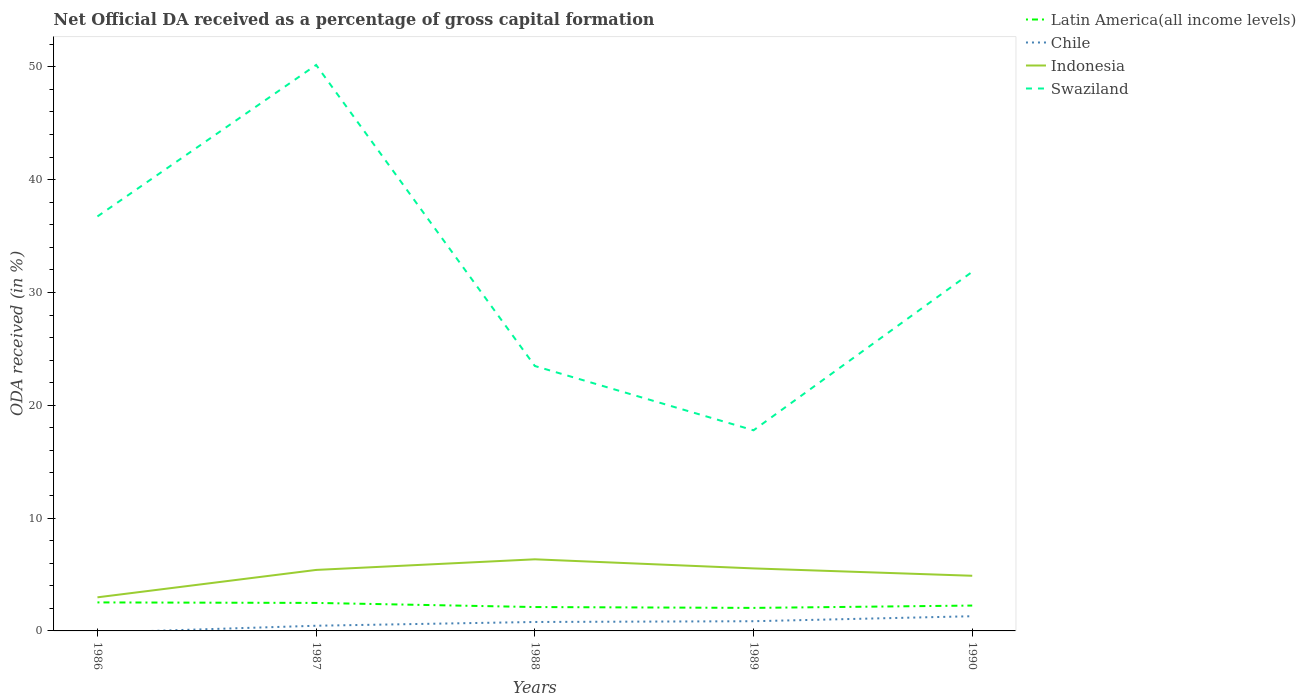Is the number of lines equal to the number of legend labels?
Your response must be concise. No. Across all years, what is the maximum net ODA received in Swaziland?
Offer a very short reply. 17.78. What is the total net ODA received in Swaziland in the graph?
Provide a short and direct response. 18.96. What is the difference between the highest and the second highest net ODA received in Chile?
Make the answer very short. 1.3. Is the net ODA received in Indonesia strictly greater than the net ODA received in Chile over the years?
Provide a short and direct response. No. How many lines are there?
Your answer should be compact. 4. How many years are there in the graph?
Offer a very short reply. 5. What is the difference between two consecutive major ticks on the Y-axis?
Offer a terse response. 10. Does the graph contain any zero values?
Make the answer very short. Yes. Does the graph contain grids?
Give a very brief answer. No. How are the legend labels stacked?
Make the answer very short. Vertical. What is the title of the graph?
Keep it short and to the point. Net Official DA received as a percentage of gross capital formation. Does "Belarus" appear as one of the legend labels in the graph?
Your response must be concise. No. What is the label or title of the X-axis?
Provide a short and direct response. Years. What is the label or title of the Y-axis?
Ensure brevity in your answer.  ODA received (in %). What is the ODA received (in %) of Latin America(all income levels) in 1986?
Your answer should be very brief. 2.53. What is the ODA received (in %) of Indonesia in 1986?
Your response must be concise. 2.98. What is the ODA received (in %) of Swaziland in 1986?
Provide a succinct answer. 36.74. What is the ODA received (in %) in Latin America(all income levels) in 1987?
Provide a succinct answer. 2.48. What is the ODA received (in %) of Chile in 1987?
Give a very brief answer. 0.46. What is the ODA received (in %) in Indonesia in 1987?
Keep it short and to the point. 5.41. What is the ODA received (in %) in Swaziland in 1987?
Offer a very short reply. 50.17. What is the ODA received (in %) of Latin America(all income levels) in 1988?
Your answer should be compact. 2.12. What is the ODA received (in %) of Chile in 1988?
Offer a terse response. 0.79. What is the ODA received (in %) in Indonesia in 1988?
Give a very brief answer. 6.35. What is the ODA received (in %) of Swaziland in 1988?
Ensure brevity in your answer.  23.48. What is the ODA received (in %) of Latin America(all income levels) in 1989?
Offer a terse response. 2.04. What is the ODA received (in %) of Chile in 1989?
Ensure brevity in your answer.  0.86. What is the ODA received (in %) in Indonesia in 1989?
Your response must be concise. 5.54. What is the ODA received (in %) of Swaziland in 1989?
Your response must be concise. 17.78. What is the ODA received (in %) of Latin America(all income levels) in 1990?
Your answer should be compact. 2.25. What is the ODA received (in %) in Chile in 1990?
Your answer should be very brief. 1.3. What is the ODA received (in %) in Indonesia in 1990?
Your answer should be compact. 4.89. What is the ODA received (in %) of Swaziland in 1990?
Give a very brief answer. 31.83. Across all years, what is the maximum ODA received (in %) in Latin America(all income levels)?
Your response must be concise. 2.53. Across all years, what is the maximum ODA received (in %) of Chile?
Provide a short and direct response. 1.3. Across all years, what is the maximum ODA received (in %) of Indonesia?
Offer a very short reply. 6.35. Across all years, what is the maximum ODA received (in %) in Swaziland?
Your answer should be compact. 50.17. Across all years, what is the minimum ODA received (in %) in Latin America(all income levels)?
Your answer should be very brief. 2.04. Across all years, what is the minimum ODA received (in %) of Indonesia?
Keep it short and to the point. 2.98. Across all years, what is the minimum ODA received (in %) in Swaziland?
Your answer should be very brief. 17.78. What is the total ODA received (in %) of Latin America(all income levels) in the graph?
Your answer should be compact. 11.42. What is the total ODA received (in %) of Chile in the graph?
Your answer should be very brief. 3.42. What is the total ODA received (in %) of Indonesia in the graph?
Ensure brevity in your answer.  25.16. What is the total ODA received (in %) of Swaziland in the graph?
Provide a short and direct response. 160.01. What is the difference between the ODA received (in %) of Latin America(all income levels) in 1986 and that in 1987?
Offer a very short reply. 0.04. What is the difference between the ODA received (in %) of Indonesia in 1986 and that in 1987?
Your response must be concise. -2.43. What is the difference between the ODA received (in %) of Swaziland in 1986 and that in 1987?
Offer a terse response. -13.43. What is the difference between the ODA received (in %) in Latin America(all income levels) in 1986 and that in 1988?
Your answer should be compact. 0.41. What is the difference between the ODA received (in %) in Indonesia in 1986 and that in 1988?
Make the answer very short. -3.37. What is the difference between the ODA received (in %) in Swaziland in 1986 and that in 1988?
Offer a terse response. 13.26. What is the difference between the ODA received (in %) of Latin America(all income levels) in 1986 and that in 1989?
Your response must be concise. 0.49. What is the difference between the ODA received (in %) in Indonesia in 1986 and that in 1989?
Your response must be concise. -2.56. What is the difference between the ODA received (in %) of Swaziland in 1986 and that in 1989?
Make the answer very short. 18.96. What is the difference between the ODA received (in %) of Latin America(all income levels) in 1986 and that in 1990?
Make the answer very short. 0.28. What is the difference between the ODA received (in %) in Indonesia in 1986 and that in 1990?
Offer a terse response. -1.91. What is the difference between the ODA received (in %) in Swaziland in 1986 and that in 1990?
Offer a terse response. 4.91. What is the difference between the ODA received (in %) in Latin America(all income levels) in 1987 and that in 1988?
Your answer should be compact. 0.37. What is the difference between the ODA received (in %) in Chile in 1987 and that in 1988?
Provide a short and direct response. -0.33. What is the difference between the ODA received (in %) in Indonesia in 1987 and that in 1988?
Make the answer very short. -0.94. What is the difference between the ODA received (in %) of Swaziland in 1987 and that in 1988?
Keep it short and to the point. 26.69. What is the difference between the ODA received (in %) of Latin America(all income levels) in 1987 and that in 1989?
Make the answer very short. 0.44. What is the difference between the ODA received (in %) in Chile in 1987 and that in 1989?
Keep it short and to the point. -0.4. What is the difference between the ODA received (in %) in Indonesia in 1987 and that in 1989?
Offer a very short reply. -0.13. What is the difference between the ODA received (in %) in Swaziland in 1987 and that in 1989?
Offer a terse response. 32.38. What is the difference between the ODA received (in %) in Latin America(all income levels) in 1987 and that in 1990?
Your answer should be compact. 0.23. What is the difference between the ODA received (in %) of Chile in 1987 and that in 1990?
Ensure brevity in your answer.  -0.84. What is the difference between the ODA received (in %) of Indonesia in 1987 and that in 1990?
Offer a terse response. 0.52. What is the difference between the ODA received (in %) of Swaziland in 1987 and that in 1990?
Provide a succinct answer. 18.34. What is the difference between the ODA received (in %) in Latin America(all income levels) in 1988 and that in 1989?
Provide a succinct answer. 0.08. What is the difference between the ODA received (in %) of Chile in 1988 and that in 1989?
Keep it short and to the point. -0.07. What is the difference between the ODA received (in %) in Indonesia in 1988 and that in 1989?
Provide a short and direct response. 0.81. What is the difference between the ODA received (in %) in Swaziland in 1988 and that in 1989?
Provide a succinct answer. 5.7. What is the difference between the ODA received (in %) of Latin America(all income levels) in 1988 and that in 1990?
Give a very brief answer. -0.13. What is the difference between the ODA received (in %) in Chile in 1988 and that in 1990?
Ensure brevity in your answer.  -0.51. What is the difference between the ODA received (in %) of Indonesia in 1988 and that in 1990?
Your answer should be compact. 1.46. What is the difference between the ODA received (in %) in Swaziland in 1988 and that in 1990?
Provide a succinct answer. -8.35. What is the difference between the ODA received (in %) in Latin America(all income levels) in 1989 and that in 1990?
Provide a succinct answer. -0.21. What is the difference between the ODA received (in %) in Chile in 1989 and that in 1990?
Your response must be concise. -0.44. What is the difference between the ODA received (in %) of Indonesia in 1989 and that in 1990?
Offer a terse response. 0.65. What is the difference between the ODA received (in %) in Swaziland in 1989 and that in 1990?
Make the answer very short. -14.05. What is the difference between the ODA received (in %) of Latin America(all income levels) in 1986 and the ODA received (in %) of Chile in 1987?
Your answer should be very brief. 2.07. What is the difference between the ODA received (in %) of Latin America(all income levels) in 1986 and the ODA received (in %) of Indonesia in 1987?
Give a very brief answer. -2.88. What is the difference between the ODA received (in %) in Latin America(all income levels) in 1986 and the ODA received (in %) in Swaziland in 1987?
Your answer should be compact. -47.64. What is the difference between the ODA received (in %) of Indonesia in 1986 and the ODA received (in %) of Swaziland in 1987?
Make the answer very short. -47.19. What is the difference between the ODA received (in %) of Latin America(all income levels) in 1986 and the ODA received (in %) of Chile in 1988?
Give a very brief answer. 1.73. What is the difference between the ODA received (in %) of Latin America(all income levels) in 1986 and the ODA received (in %) of Indonesia in 1988?
Give a very brief answer. -3.82. What is the difference between the ODA received (in %) of Latin America(all income levels) in 1986 and the ODA received (in %) of Swaziland in 1988?
Your answer should be compact. -20.96. What is the difference between the ODA received (in %) of Indonesia in 1986 and the ODA received (in %) of Swaziland in 1988?
Make the answer very short. -20.5. What is the difference between the ODA received (in %) in Latin America(all income levels) in 1986 and the ODA received (in %) in Chile in 1989?
Provide a succinct answer. 1.67. What is the difference between the ODA received (in %) in Latin America(all income levels) in 1986 and the ODA received (in %) in Indonesia in 1989?
Your answer should be compact. -3.01. What is the difference between the ODA received (in %) in Latin America(all income levels) in 1986 and the ODA received (in %) in Swaziland in 1989?
Ensure brevity in your answer.  -15.26. What is the difference between the ODA received (in %) of Indonesia in 1986 and the ODA received (in %) of Swaziland in 1989?
Offer a terse response. -14.81. What is the difference between the ODA received (in %) in Latin America(all income levels) in 1986 and the ODA received (in %) in Chile in 1990?
Offer a terse response. 1.22. What is the difference between the ODA received (in %) of Latin America(all income levels) in 1986 and the ODA received (in %) of Indonesia in 1990?
Provide a short and direct response. -2.36. What is the difference between the ODA received (in %) of Latin America(all income levels) in 1986 and the ODA received (in %) of Swaziland in 1990?
Your answer should be compact. -29.31. What is the difference between the ODA received (in %) in Indonesia in 1986 and the ODA received (in %) in Swaziland in 1990?
Provide a short and direct response. -28.85. What is the difference between the ODA received (in %) in Latin America(all income levels) in 1987 and the ODA received (in %) in Chile in 1988?
Give a very brief answer. 1.69. What is the difference between the ODA received (in %) of Latin America(all income levels) in 1987 and the ODA received (in %) of Indonesia in 1988?
Your answer should be compact. -3.87. What is the difference between the ODA received (in %) of Latin America(all income levels) in 1987 and the ODA received (in %) of Swaziland in 1988?
Your answer should be compact. -21. What is the difference between the ODA received (in %) of Chile in 1987 and the ODA received (in %) of Indonesia in 1988?
Offer a terse response. -5.89. What is the difference between the ODA received (in %) of Chile in 1987 and the ODA received (in %) of Swaziland in 1988?
Give a very brief answer. -23.02. What is the difference between the ODA received (in %) of Indonesia in 1987 and the ODA received (in %) of Swaziland in 1988?
Your answer should be compact. -18.08. What is the difference between the ODA received (in %) in Latin America(all income levels) in 1987 and the ODA received (in %) in Chile in 1989?
Your answer should be very brief. 1.62. What is the difference between the ODA received (in %) of Latin America(all income levels) in 1987 and the ODA received (in %) of Indonesia in 1989?
Offer a terse response. -3.06. What is the difference between the ODA received (in %) in Latin America(all income levels) in 1987 and the ODA received (in %) in Swaziland in 1989?
Ensure brevity in your answer.  -15.3. What is the difference between the ODA received (in %) in Chile in 1987 and the ODA received (in %) in Indonesia in 1989?
Make the answer very short. -5.08. What is the difference between the ODA received (in %) of Chile in 1987 and the ODA received (in %) of Swaziland in 1989?
Your answer should be very brief. -17.32. What is the difference between the ODA received (in %) in Indonesia in 1987 and the ODA received (in %) in Swaziland in 1989?
Your answer should be compact. -12.38. What is the difference between the ODA received (in %) in Latin America(all income levels) in 1987 and the ODA received (in %) in Chile in 1990?
Offer a very short reply. 1.18. What is the difference between the ODA received (in %) of Latin America(all income levels) in 1987 and the ODA received (in %) of Indonesia in 1990?
Ensure brevity in your answer.  -2.41. What is the difference between the ODA received (in %) in Latin America(all income levels) in 1987 and the ODA received (in %) in Swaziland in 1990?
Provide a succinct answer. -29.35. What is the difference between the ODA received (in %) in Chile in 1987 and the ODA received (in %) in Indonesia in 1990?
Your response must be concise. -4.43. What is the difference between the ODA received (in %) in Chile in 1987 and the ODA received (in %) in Swaziland in 1990?
Provide a short and direct response. -31.37. What is the difference between the ODA received (in %) in Indonesia in 1987 and the ODA received (in %) in Swaziland in 1990?
Your answer should be compact. -26.43. What is the difference between the ODA received (in %) of Latin America(all income levels) in 1988 and the ODA received (in %) of Chile in 1989?
Provide a succinct answer. 1.26. What is the difference between the ODA received (in %) of Latin America(all income levels) in 1988 and the ODA received (in %) of Indonesia in 1989?
Keep it short and to the point. -3.42. What is the difference between the ODA received (in %) in Latin America(all income levels) in 1988 and the ODA received (in %) in Swaziland in 1989?
Your answer should be very brief. -15.67. What is the difference between the ODA received (in %) in Chile in 1988 and the ODA received (in %) in Indonesia in 1989?
Your answer should be compact. -4.75. What is the difference between the ODA received (in %) in Chile in 1988 and the ODA received (in %) in Swaziland in 1989?
Provide a short and direct response. -16.99. What is the difference between the ODA received (in %) in Indonesia in 1988 and the ODA received (in %) in Swaziland in 1989?
Give a very brief answer. -11.44. What is the difference between the ODA received (in %) of Latin America(all income levels) in 1988 and the ODA received (in %) of Chile in 1990?
Ensure brevity in your answer.  0.81. What is the difference between the ODA received (in %) of Latin America(all income levels) in 1988 and the ODA received (in %) of Indonesia in 1990?
Give a very brief answer. -2.77. What is the difference between the ODA received (in %) in Latin America(all income levels) in 1988 and the ODA received (in %) in Swaziland in 1990?
Make the answer very short. -29.72. What is the difference between the ODA received (in %) of Chile in 1988 and the ODA received (in %) of Indonesia in 1990?
Ensure brevity in your answer.  -4.1. What is the difference between the ODA received (in %) of Chile in 1988 and the ODA received (in %) of Swaziland in 1990?
Offer a very short reply. -31.04. What is the difference between the ODA received (in %) in Indonesia in 1988 and the ODA received (in %) in Swaziland in 1990?
Ensure brevity in your answer.  -25.48. What is the difference between the ODA received (in %) of Latin America(all income levels) in 1989 and the ODA received (in %) of Chile in 1990?
Provide a succinct answer. 0.74. What is the difference between the ODA received (in %) in Latin America(all income levels) in 1989 and the ODA received (in %) in Indonesia in 1990?
Keep it short and to the point. -2.85. What is the difference between the ODA received (in %) of Latin America(all income levels) in 1989 and the ODA received (in %) of Swaziland in 1990?
Provide a short and direct response. -29.79. What is the difference between the ODA received (in %) of Chile in 1989 and the ODA received (in %) of Indonesia in 1990?
Offer a very short reply. -4.03. What is the difference between the ODA received (in %) in Chile in 1989 and the ODA received (in %) in Swaziland in 1990?
Offer a terse response. -30.97. What is the difference between the ODA received (in %) of Indonesia in 1989 and the ODA received (in %) of Swaziland in 1990?
Your answer should be compact. -26.29. What is the average ODA received (in %) of Latin America(all income levels) per year?
Keep it short and to the point. 2.28. What is the average ODA received (in %) of Chile per year?
Keep it short and to the point. 0.68. What is the average ODA received (in %) of Indonesia per year?
Your response must be concise. 5.03. What is the average ODA received (in %) in Swaziland per year?
Make the answer very short. 32. In the year 1986, what is the difference between the ODA received (in %) in Latin America(all income levels) and ODA received (in %) in Indonesia?
Give a very brief answer. -0.45. In the year 1986, what is the difference between the ODA received (in %) in Latin America(all income levels) and ODA received (in %) in Swaziland?
Provide a succinct answer. -34.21. In the year 1986, what is the difference between the ODA received (in %) in Indonesia and ODA received (in %) in Swaziland?
Your answer should be very brief. -33.76. In the year 1987, what is the difference between the ODA received (in %) in Latin America(all income levels) and ODA received (in %) in Chile?
Keep it short and to the point. 2.02. In the year 1987, what is the difference between the ODA received (in %) of Latin America(all income levels) and ODA received (in %) of Indonesia?
Your response must be concise. -2.92. In the year 1987, what is the difference between the ODA received (in %) in Latin America(all income levels) and ODA received (in %) in Swaziland?
Ensure brevity in your answer.  -47.69. In the year 1987, what is the difference between the ODA received (in %) of Chile and ODA received (in %) of Indonesia?
Provide a short and direct response. -4.95. In the year 1987, what is the difference between the ODA received (in %) in Chile and ODA received (in %) in Swaziland?
Ensure brevity in your answer.  -49.71. In the year 1987, what is the difference between the ODA received (in %) in Indonesia and ODA received (in %) in Swaziland?
Make the answer very short. -44.76. In the year 1988, what is the difference between the ODA received (in %) of Latin America(all income levels) and ODA received (in %) of Chile?
Provide a short and direct response. 1.32. In the year 1988, what is the difference between the ODA received (in %) in Latin America(all income levels) and ODA received (in %) in Indonesia?
Provide a short and direct response. -4.23. In the year 1988, what is the difference between the ODA received (in %) of Latin America(all income levels) and ODA received (in %) of Swaziland?
Keep it short and to the point. -21.37. In the year 1988, what is the difference between the ODA received (in %) in Chile and ODA received (in %) in Indonesia?
Keep it short and to the point. -5.55. In the year 1988, what is the difference between the ODA received (in %) in Chile and ODA received (in %) in Swaziland?
Offer a terse response. -22.69. In the year 1988, what is the difference between the ODA received (in %) of Indonesia and ODA received (in %) of Swaziland?
Provide a succinct answer. -17.14. In the year 1989, what is the difference between the ODA received (in %) of Latin America(all income levels) and ODA received (in %) of Chile?
Offer a terse response. 1.18. In the year 1989, what is the difference between the ODA received (in %) in Latin America(all income levels) and ODA received (in %) in Indonesia?
Ensure brevity in your answer.  -3.5. In the year 1989, what is the difference between the ODA received (in %) of Latin America(all income levels) and ODA received (in %) of Swaziland?
Provide a succinct answer. -15.74. In the year 1989, what is the difference between the ODA received (in %) of Chile and ODA received (in %) of Indonesia?
Give a very brief answer. -4.68. In the year 1989, what is the difference between the ODA received (in %) in Chile and ODA received (in %) in Swaziland?
Ensure brevity in your answer.  -16.92. In the year 1989, what is the difference between the ODA received (in %) in Indonesia and ODA received (in %) in Swaziland?
Give a very brief answer. -12.24. In the year 1990, what is the difference between the ODA received (in %) in Latin America(all income levels) and ODA received (in %) in Chile?
Give a very brief answer. 0.94. In the year 1990, what is the difference between the ODA received (in %) in Latin America(all income levels) and ODA received (in %) in Indonesia?
Your answer should be compact. -2.64. In the year 1990, what is the difference between the ODA received (in %) of Latin America(all income levels) and ODA received (in %) of Swaziland?
Provide a succinct answer. -29.58. In the year 1990, what is the difference between the ODA received (in %) in Chile and ODA received (in %) in Indonesia?
Keep it short and to the point. -3.59. In the year 1990, what is the difference between the ODA received (in %) of Chile and ODA received (in %) of Swaziland?
Ensure brevity in your answer.  -30.53. In the year 1990, what is the difference between the ODA received (in %) of Indonesia and ODA received (in %) of Swaziland?
Offer a very short reply. -26.94. What is the ratio of the ODA received (in %) of Indonesia in 1986 to that in 1987?
Offer a very short reply. 0.55. What is the ratio of the ODA received (in %) of Swaziland in 1986 to that in 1987?
Give a very brief answer. 0.73. What is the ratio of the ODA received (in %) of Latin America(all income levels) in 1986 to that in 1988?
Provide a short and direct response. 1.19. What is the ratio of the ODA received (in %) of Indonesia in 1986 to that in 1988?
Make the answer very short. 0.47. What is the ratio of the ODA received (in %) in Swaziland in 1986 to that in 1988?
Give a very brief answer. 1.56. What is the ratio of the ODA received (in %) of Latin America(all income levels) in 1986 to that in 1989?
Give a very brief answer. 1.24. What is the ratio of the ODA received (in %) of Indonesia in 1986 to that in 1989?
Keep it short and to the point. 0.54. What is the ratio of the ODA received (in %) in Swaziland in 1986 to that in 1989?
Keep it short and to the point. 2.07. What is the ratio of the ODA received (in %) in Latin America(all income levels) in 1986 to that in 1990?
Provide a succinct answer. 1.12. What is the ratio of the ODA received (in %) of Indonesia in 1986 to that in 1990?
Your response must be concise. 0.61. What is the ratio of the ODA received (in %) of Swaziland in 1986 to that in 1990?
Offer a very short reply. 1.15. What is the ratio of the ODA received (in %) in Latin America(all income levels) in 1987 to that in 1988?
Make the answer very short. 1.17. What is the ratio of the ODA received (in %) of Chile in 1987 to that in 1988?
Keep it short and to the point. 0.58. What is the ratio of the ODA received (in %) in Indonesia in 1987 to that in 1988?
Offer a very short reply. 0.85. What is the ratio of the ODA received (in %) of Swaziland in 1987 to that in 1988?
Give a very brief answer. 2.14. What is the ratio of the ODA received (in %) of Latin America(all income levels) in 1987 to that in 1989?
Provide a succinct answer. 1.22. What is the ratio of the ODA received (in %) in Chile in 1987 to that in 1989?
Ensure brevity in your answer.  0.53. What is the ratio of the ODA received (in %) in Indonesia in 1987 to that in 1989?
Keep it short and to the point. 0.98. What is the ratio of the ODA received (in %) in Swaziland in 1987 to that in 1989?
Make the answer very short. 2.82. What is the ratio of the ODA received (in %) of Latin America(all income levels) in 1987 to that in 1990?
Offer a very short reply. 1.1. What is the ratio of the ODA received (in %) in Chile in 1987 to that in 1990?
Your response must be concise. 0.35. What is the ratio of the ODA received (in %) of Indonesia in 1987 to that in 1990?
Make the answer very short. 1.11. What is the ratio of the ODA received (in %) in Swaziland in 1987 to that in 1990?
Keep it short and to the point. 1.58. What is the ratio of the ODA received (in %) in Latin America(all income levels) in 1988 to that in 1989?
Your answer should be compact. 1.04. What is the ratio of the ODA received (in %) of Chile in 1988 to that in 1989?
Offer a very short reply. 0.92. What is the ratio of the ODA received (in %) of Indonesia in 1988 to that in 1989?
Your response must be concise. 1.15. What is the ratio of the ODA received (in %) in Swaziland in 1988 to that in 1989?
Give a very brief answer. 1.32. What is the ratio of the ODA received (in %) of Latin America(all income levels) in 1988 to that in 1990?
Provide a succinct answer. 0.94. What is the ratio of the ODA received (in %) in Chile in 1988 to that in 1990?
Your response must be concise. 0.61. What is the ratio of the ODA received (in %) in Indonesia in 1988 to that in 1990?
Ensure brevity in your answer.  1.3. What is the ratio of the ODA received (in %) in Swaziland in 1988 to that in 1990?
Offer a terse response. 0.74. What is the ratio of the ODA received (in %) of Latin America(all income levels) in 1989 to that in 1990?
Offer a very short reply. 0.91. What is the ratio of the ODA received (in %) of Chile in 1989 to that in 1990?
Keep it short and to the point. 0.66. What is the ratio of the ODA received (in %) of Indonesia in 1989 to that in 1990?
Your answer should be very brief. 1.13. What is the ratio of the ODA received (in %) in Swaziland in 1989 to that in 1990?
Provide a short and direct response. 0.56. What is the difference between the highest and the second highest ODA received (in %) in Latin America(all income levels)?
Offer a terse response. 0.04. What is the difference between the highest and the second highest ODA received (in %) in Chile?
Provide a short and direct response. 0.44. What is the difference between the highest and the second highest ODA received (in %) of Indonesia?
Your answer should be compact. 0.81. What is the difference between the highest and the second highest ODA received (in %) in Swaziland?
Keep it short and to the point. 13.43. What is the difference between the highest and the lowest ODA received (in %) of Latin America(all income levels)?
Give a very brief answer. 0.49. What is the difference between the highest and the lowest ODA received (in %) in Chile?
Keep it short and to the point. 1.3. What is the difference between the highest and the lowest ODA received (in %) in Indonesia?
Your answer should be very brief. 3.37. What is the difference between the highest and the lowest ODA received (in %) in Swaziland?
Your answer should be very brief. 32.38. 